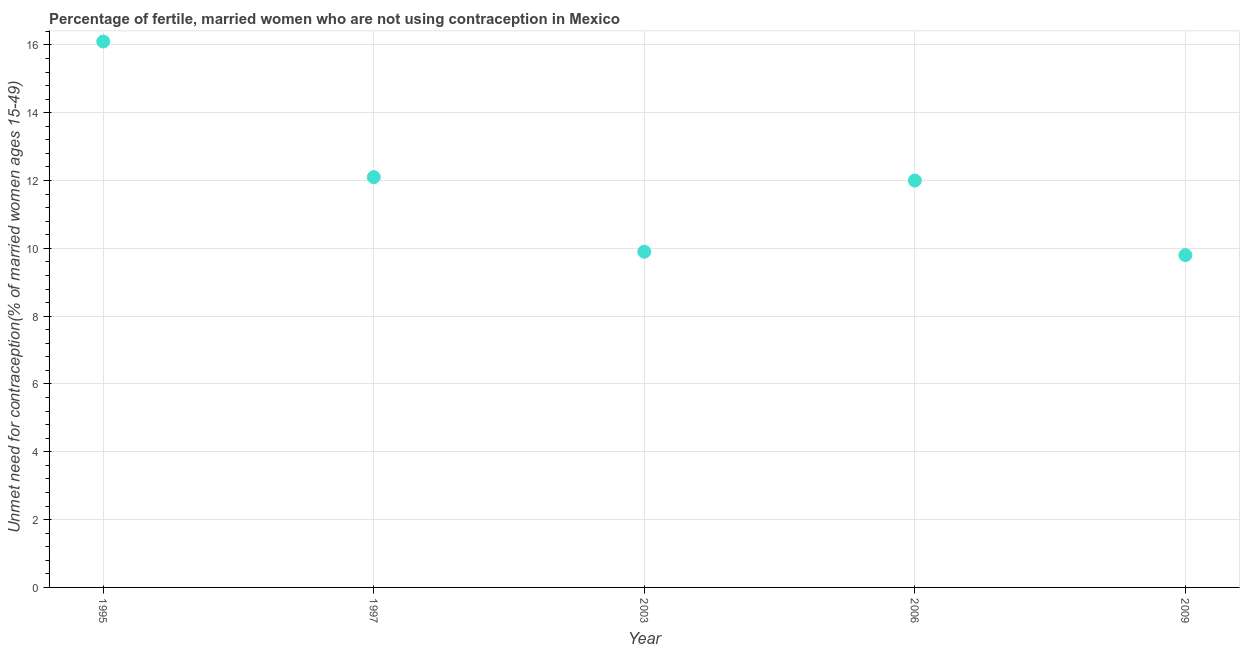Across all years, what is the maximum number of married women who are not using contraception?
Provide a succinct answer. 16.1. In which year was the number of married women who are not using contraception minimum?
Provide a short and direct response. 2009. What is the sum of the number of married women who are not using contraception?
Make the answer very short. 59.9. What is the difference between the number of married women who are not using contraception in 1995 and 2006?
Offer a terse response. 4.1. What is the average number of married women who are not using contraception per year?
Make the answer very short. 11.98. What is the ratio of the number of married women who are not using contraception in 2003 to that in 2006?
Offer a very short reply. 0.83. Is the number of married women who are not using contraception in 1995 less than that in 1997?
Provide a short and direct response. No. Is the difference between the number of married women who are not using contraception in 1995 and 2009 greater than the difference between any two years?
Provide a short and direct response. Yes. What is the difference between the highest and the second highest number of married women who are not using contraception?
Keep it short and to the point. 4. What is the difference between the highest and the lowest number of married women who are not using contraception?
Your answer should be very brief. 6.3. How many years are there in the graph?
Ensure brevity in your answer.  5. Does the graph contain grids?
Offer a terse response. Yes. What is the title of the graph?
Keep it short and to the point. Percentage of fertile, married women who are not using contraception in Mexico. What is the label or title of the X-axis?
Provide a short and direct response. Year. What is the label or title of the Y-axis?
Provide a succinct answer.  Unmet need for contraception(% of married women ages 15-49). What is the  Unmet need for contraception(% of married women ages 15-49) in 1995?
Keep it short and to the point. 16.1. What is the  Unmet need for contraception(% of married women ages 15-49) in 2006?
Make the answer very short. 12. What is the  Unmet need for contraception(% of married women ages 15-49) in 2009?
Provide a succinct answer. 9.8. What is the difference between the  Unmet need for contraception(% of married women ages 15-49) in 1995 and 2009?
Your response must be concise. 6.3. What is the difference between the  Unmet need for contraception(% of married women ages 15-49) in 1997 and 2006?
Ensure brevity in your answer.  0.1. What is the difference between the  Unmet need for contraception(% of married women ages 15-49) in 2003 and 2006?
Your response must be concise. -2.1. What is the difference between the  Unmet need for contraception(% of married women ages 15-49) in 2006 and 2009?
Provide a short and direct response. 2.2. What is the ratio of the  Unmet need for contraception(% of married women ages 15-49) in 1995 to that in 1997?
Your answer should be compact. 1.33. What is the ratio of the  Unmet need for contraception(% of married women ages 15-49) in 1995 to that in 2003?
Make the answer very short. 1.63. What is the ratio of the  Unmet need for contraception(% of married women ages 15-49) in 1995 to that in 2006?
Your response must be concise. 1.34. What is the ratio of the  Unmet need for contraception(% of married women ages 15-49) in 1995 to that in 2009?
Provide a short and direct response. 1.64. What is the ratio of the  Unmet need for contraception(% of married women ages 15-49) in 1997 to that in 2003?
Offer a terse response. 1.22. What is the ratio of the  Unmet need for contraception(% of married women ages 15-49) in 1997 to that in 2009?
Provide a succinct answer. 1.24. What is the ratio of the  Unmet need for contraception(% of married women ages 15-49) in 2003 to that in 2006?
Provide a succinct answer. 0.82. What is the ratio of the  Unmet need for contraception(% of married women ages 15-49) in 2003 to that in 2009?
Offer a very short reply. 1.01. What is the ratio of the  Unmet need for contraception(% of married women ages 15-49) in 2006 to that in 2009?
Keep it short and to the point. 1.22. 